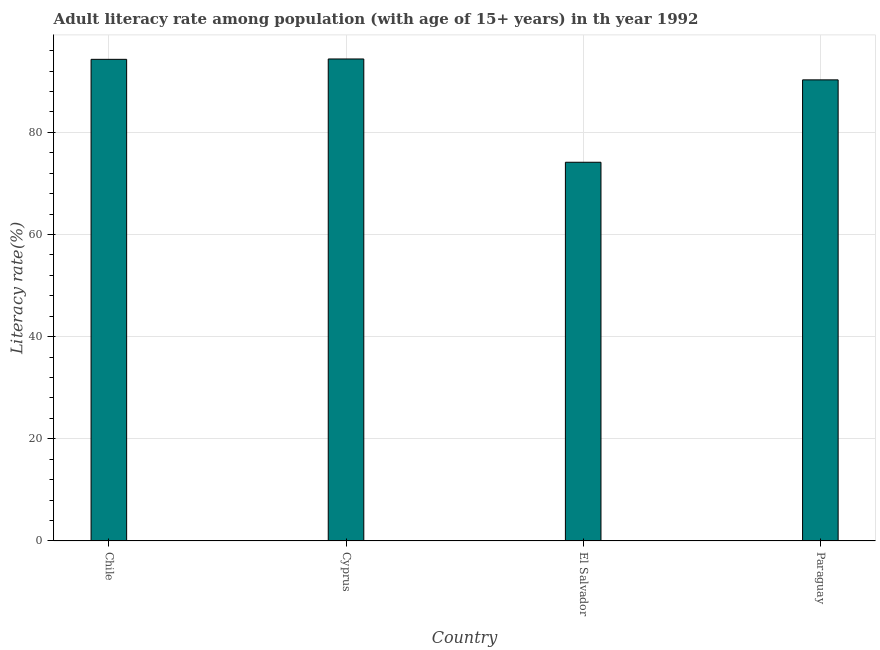What is the title of the graph?
Keep it short and to the point. Adult literacy rate among population (with age of 15+ years) in th year 1992. What is the label or title of the X-axis?
Offer a terse response. Country. What is the label or title of the Y-axis?
Provide a short and direct response. Literacy rate(%). What is the adult literacy rate in Cyprus?
Offer a very short reply. 94.36. Across all countries, what is the maximum adult literacy rate?
Ensure brevity in your answer.  94.36. Across all countries, what is the minimum adult literacy rate?
Ensure brevity in your answer.  74.14. In which country was the adult literacy rate maximum?
Provide a short and direct response. Cyprus. In which country was the adult literacy rate minimum?
Offer a very short reply. El Salvador. What is the sum of the adult literacy rate?
Offer a terse response. 353.07. What is the difference between the adult literacy rate in Cyprus and Paraguay?
Your answer should be very brief. 4.09. What is the average adult literacy rate per country?
Ensure brevity in your answer.  88.27. What is the median adult literacy rate?
Your answer should be very brief. 92.28. In how many countries, is the adult literacy rate greater than 68 %?
Keep it short and to the point. 4. What is the ratio of the adult literacy rate in Chile to that in El Salvador?
Offer a very short reply. 1.27. Is the adult literacy rate in Chile less than that in Cyprus?
Keep it short and to the point. Yes. Is the difference between the adult literacy rate in Chile and Cyprus greater than the difference between any two countries?
Keep it short and to the point. No. What is the difference between the highest and the second highest adult literacy rate?
Your response must be concise. 0.07. What is the difference between the highest and the lowest adult literacy rate?
Give a very brief answer. 20.22. How many countries are there in the graph?
Give a very brief answer. 4. Are the values on the major ticks of Y-axis written in scientific E-notation?
Make the answer very short. No. What is the Literacy rate(%) in Chile?
Provide a short and direct response. 94.29. What is the Literacy rate(%) of Cyprus?
Offer a very short reply. 94.36. What is the Literacy rate(%) in El Salvador?
Your answer should be very brief. 74.14. What is the Literacy rate(%) in Paraguay?
Ensure brevity in your answer.  90.27. What is the difference between the Literacy rate(%) in Chile and Cyprus?
Offer a very short reply. -0.07. What is the difference between the Literacy rate(%) in Chile and El Salvador?
Give a very brief answer. 20.15. What is the difference between the Literacy rate(%) in Chile and Paraguay?
Your answer should be compact. 4.02. What is the difference between the Literacy rate(%) in Cyprus and El Salvador?
Offer a terse response. 20.22. What is the difference between the Literacy rate(%) in Cyprus and Paraguay?
Keep it short and to the point. 4.09. What is the difference between the Literacy rate(%) in El Salvador and Paraguay?
Make the answer very short. -16.13. What is the ratio of the Literacy rate(%) in Chile to that in Cyprus?
Your answer should be very brief. 1. What is the ratio of the Literacy rate(%) in Chile to that in El Salvador?
Offer a very short reply. 1.27. What is the ratio of the Literacy rate(%) in Chile to that in Paraguay?
Your answer should be compact. 1.04. What is the ratio of the Literacy rate(%) in Cyprus to that in El Salvador?
Keep it short and to the point. 1.27. What is the ratio of the Literacy rate(%) in Cyprus to that in Paraguay?
Your answer should be very brief. 1.04. What is the ratio of the Literacy rate(%) in El Salvador to that in Paraguay?
Your response must be concise. 0.82. 